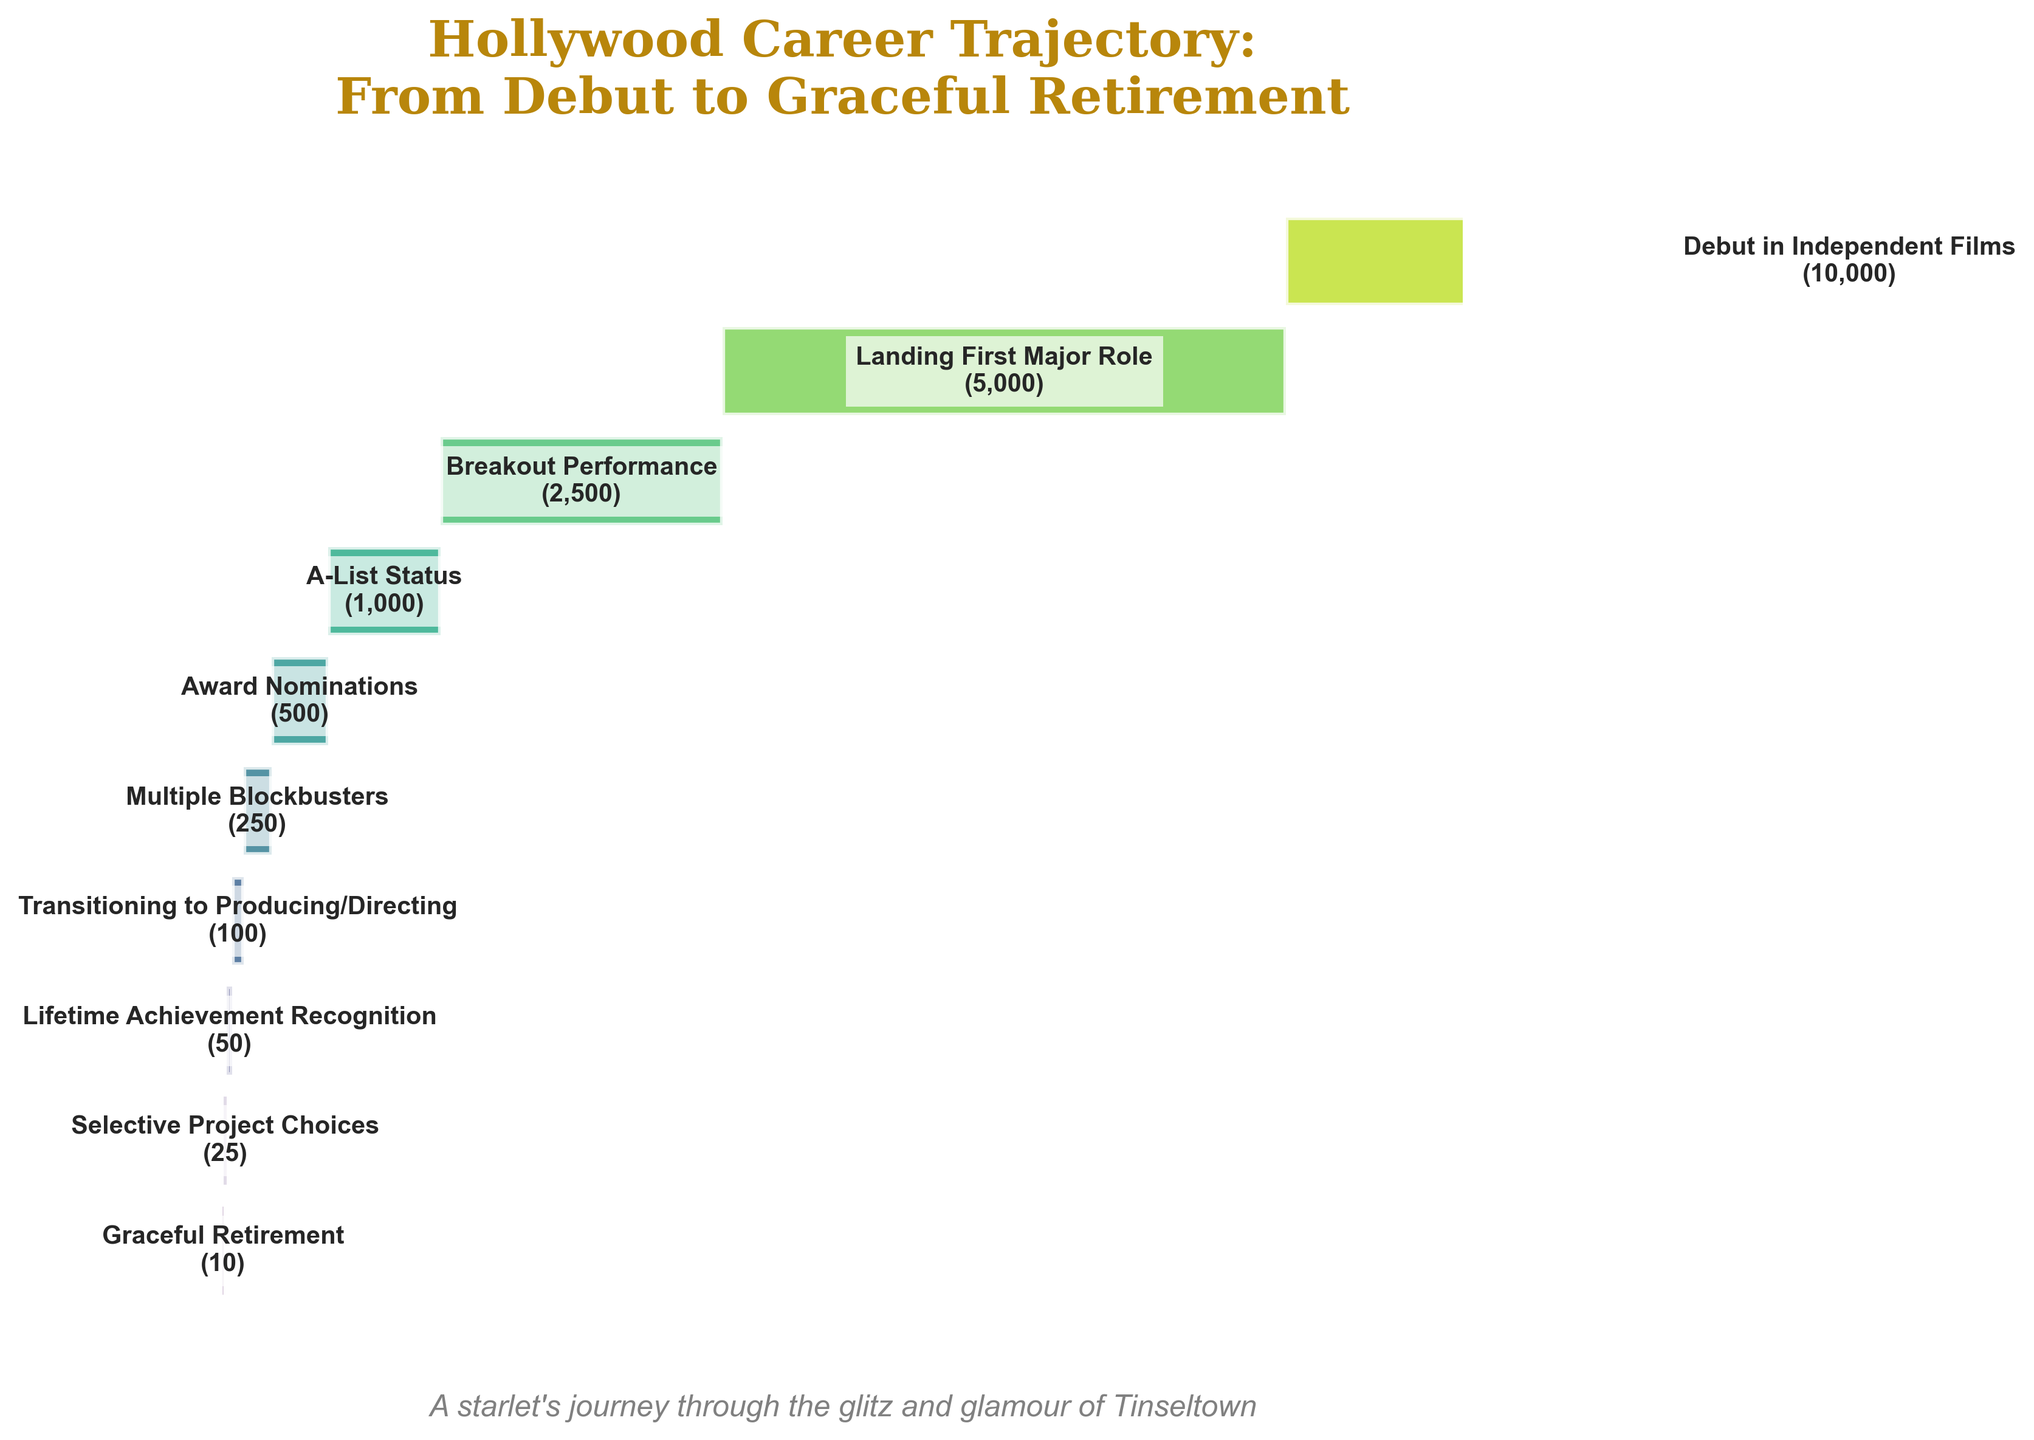What is the title of the funnel chart? The title is usually placed at the top center of the chart. In this case, it is written in a large and glamorous style.
Answer: "Hollywood Career Trajectory: From Debut to Graceful Retirement" Which stage has the highest number of actors? The stage with the highest number of actors is usually located at the top of the funnel chart, where the width of the bar is the largest.
Answer: Debut in Independent Films How many actors reached the stage of A-List Status? Look for the label corresponding to 'A-List Status' and read the number next to it or inside the bar.
Answer: 1,000 What is the difference in the number of actors between 'Landing First Major Role' and 'Breakout Performance'? Subtract the number of actors in 'Breakout Performance' from the number in 'Landing First Major Role'.
Answer: 5,000 - 2,500 = 2,500 How many actors transition to producing/directing? Identify the label 'Transitioning to Producing/Directing' and read the number associated with it.
Answer: 100 What is the average number of actors per stage across all the stages showing in the funnel? Sum all the actors from each stage and divide by the number of stages. This calculation involves (10,000 + 5,000 + 2,500 + 1,000 + 500 + 250 + 100 + 50 + 25 + 10) / 10.
Answer: 1933.5 How does the number of actors who received award nominations compare to those who have multiple blockbusters? Identify the values for these two stages and compare them.
Answer: 500 for Award Nominations, 250 for Multiple Blockbusters. The number of actors who received award nominations is greater Describe the biggest drop in the number of actors between two consecutive stages. Identify the largest difference by examining the decreasing numbers step-by-step between stages. The largest drop is between 'Debut in Independent Films' (10,000) and 'Landing First Major Role' (5,000), which is a drop of 5,000.
Answer: 5,000 What fraction of the original number of actors achieve a lifetime achievement recognition? Divide the number of actors in 'Lifetime Achievement Recognition' by the number in 'Debut in Independent Films'. This is 50 / 10,000 = 0.005 or 0.5%.
Answer: 0.5% How many more actors are in 'Breakout Performance' compared to 'Multiple Blockbusters'? Subtract the number of actors in 'Multiple Blockbusters' from the number in 'Breakout Performance'.
Answer: 2,500 - 250 = 2,250 